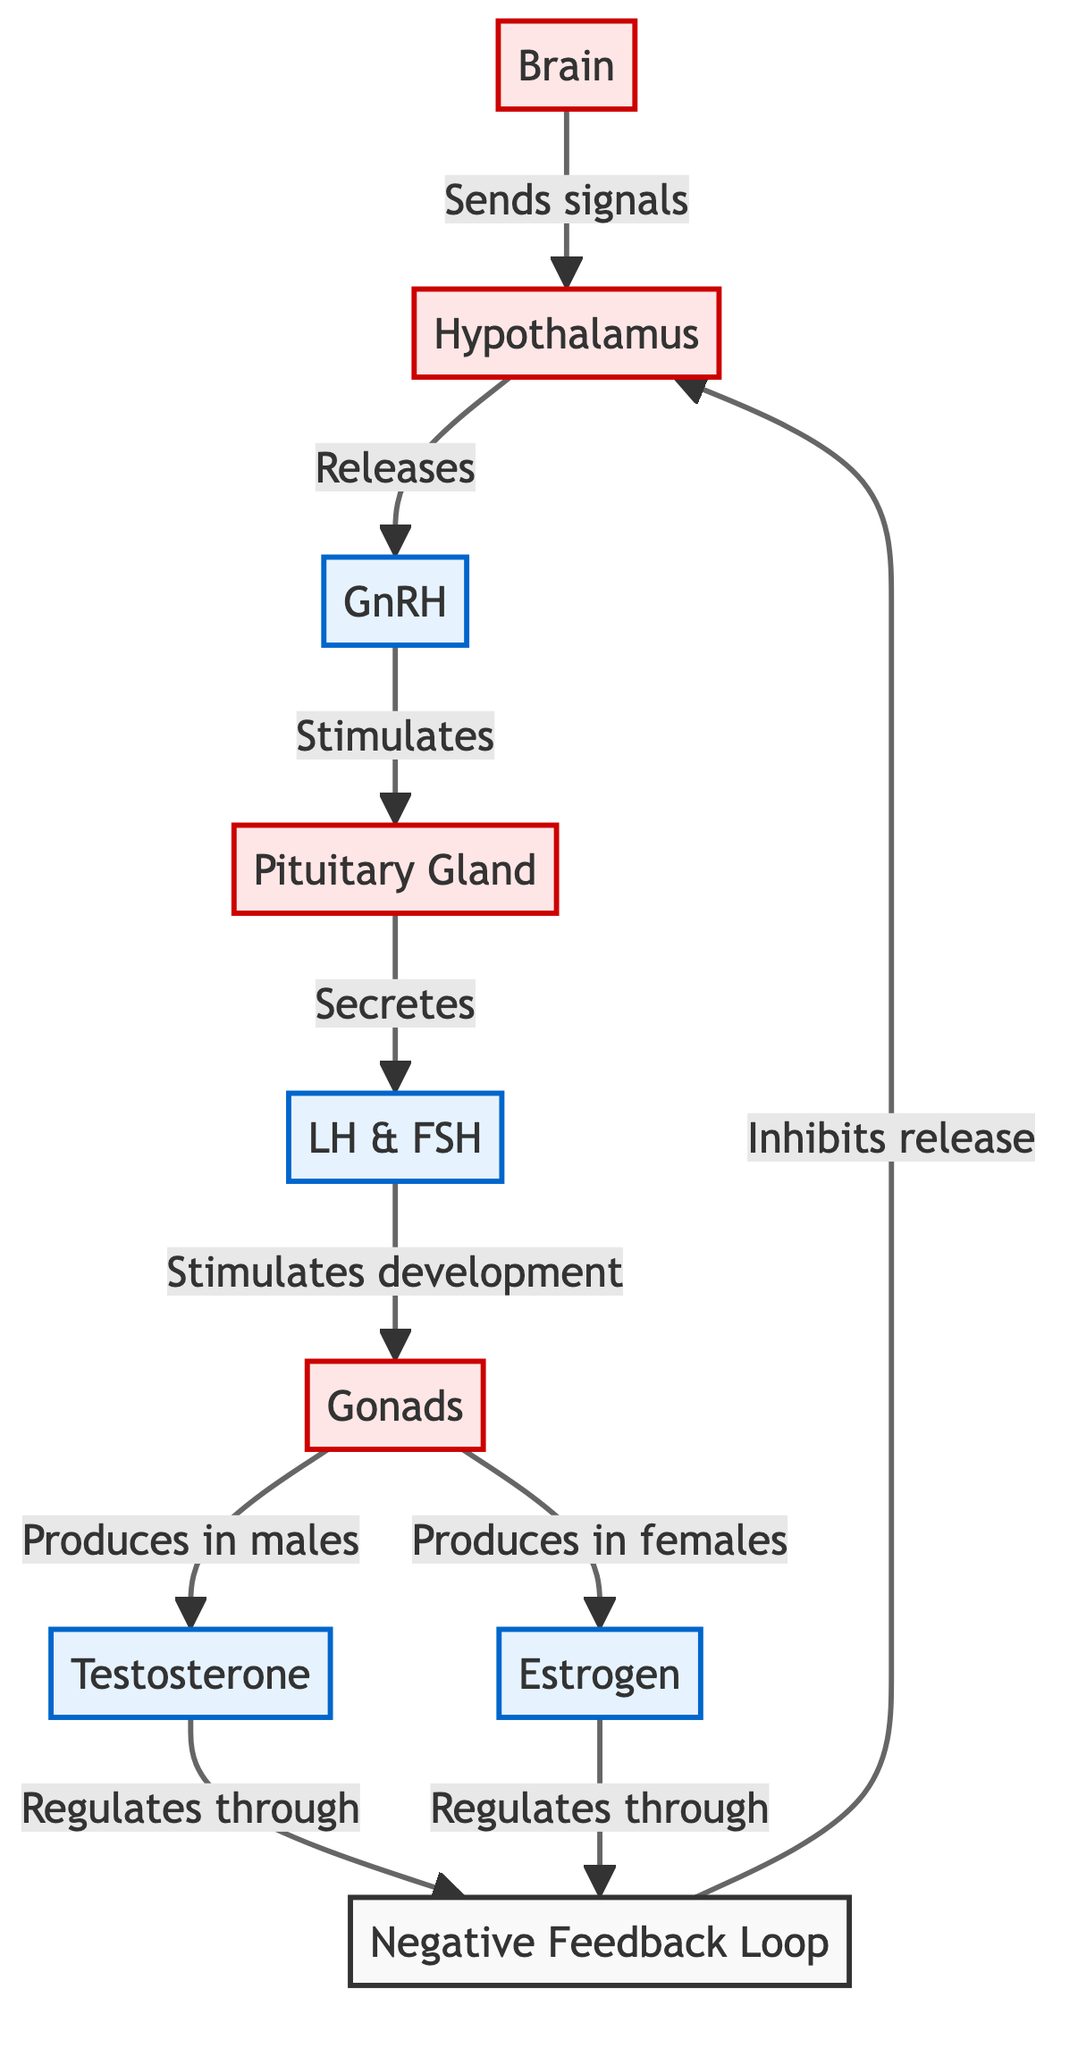What is released by the hypothalamus? The diagram shows that the hypothalamus releases GnRH. This is directly indicated by the arrow pointing from the hypothalamus to GnRH.
Answer: GnRH How many hormones are shown in the diagram? The diagram displays three hormones: GnRH, LH & FSH, testosterone, and estrogen. Counting these gives us a total of four distinct hormones.
Answer: 4 What stimulates the pituitary gland? The GnRH released by the hypothalamus stimulates the pituitary gland, as represented by the arrow connecting GnRH to the pituitary gland.
Answer: GnRH Which organ produces testosterone? The gonads produce testosterone according to the arrow labeled "Produces in males". This relationship is shown directly in the diagram.
Answer: Gonads What is the feedback mechanism described in the diagram? The feedback mechanism includes negative feedback from testosterone and estrogen that inhibits the release of GnRH from the hypothalamus. This is shown by the arrows returning from the hormones to the hypothalamus.
Answer: Negative Feedback Loop Which hormones are indicated to be regulated by feedback? The diagram indicates that both testosterone and estrogen are regulated through the feedback mechanism. This is identified by the arrows coming from both testosterone and estrogen pointing towards the feedback loop.
Answer: Testosterone and Estrogen What does LH & FSH stimulate? LH & FSH stimulates the development of gonads as shown in the arrow pointing from LH & FSH to the gonads.
Answer: Gonads Which part of the brain sends signals? The brain is noted as the part that sends signals to the hypothalamus, as indicated by the arrow directing from the brain to the hypothalamus.
Answer: Brain What is the primary function of the gonads in females according to the diagram? The primary function of the gonads in females is to produce estrogen, as indicated by the arrow labeled "Produces in females".
Answer: Estrogen 